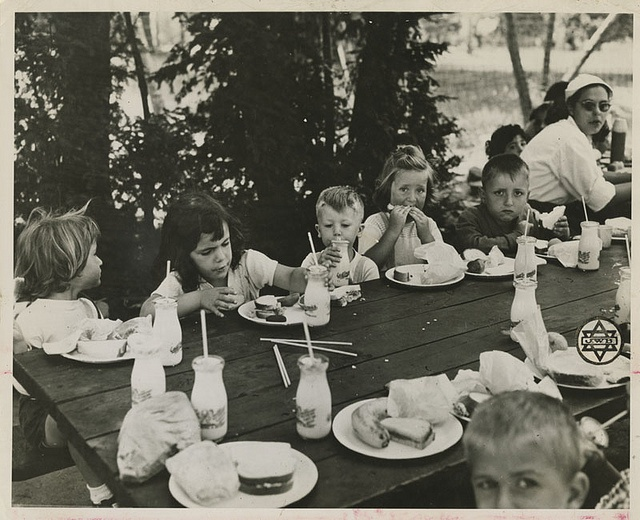Describe the objects in this image and their specific colors. I can see dining table in beige, black, darkgray, and gray tones, people in beige, gray, black, and darkgray tones, people in beige, black, gray, and darkgray tones, people in beige, gray, black, and lightgray tones, and people in beige, darkgray, lightgray, gray, and black tones in this image. 